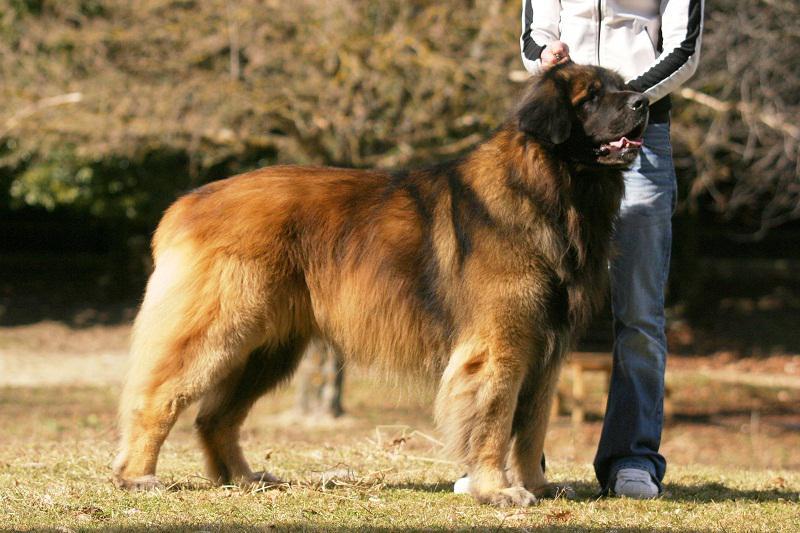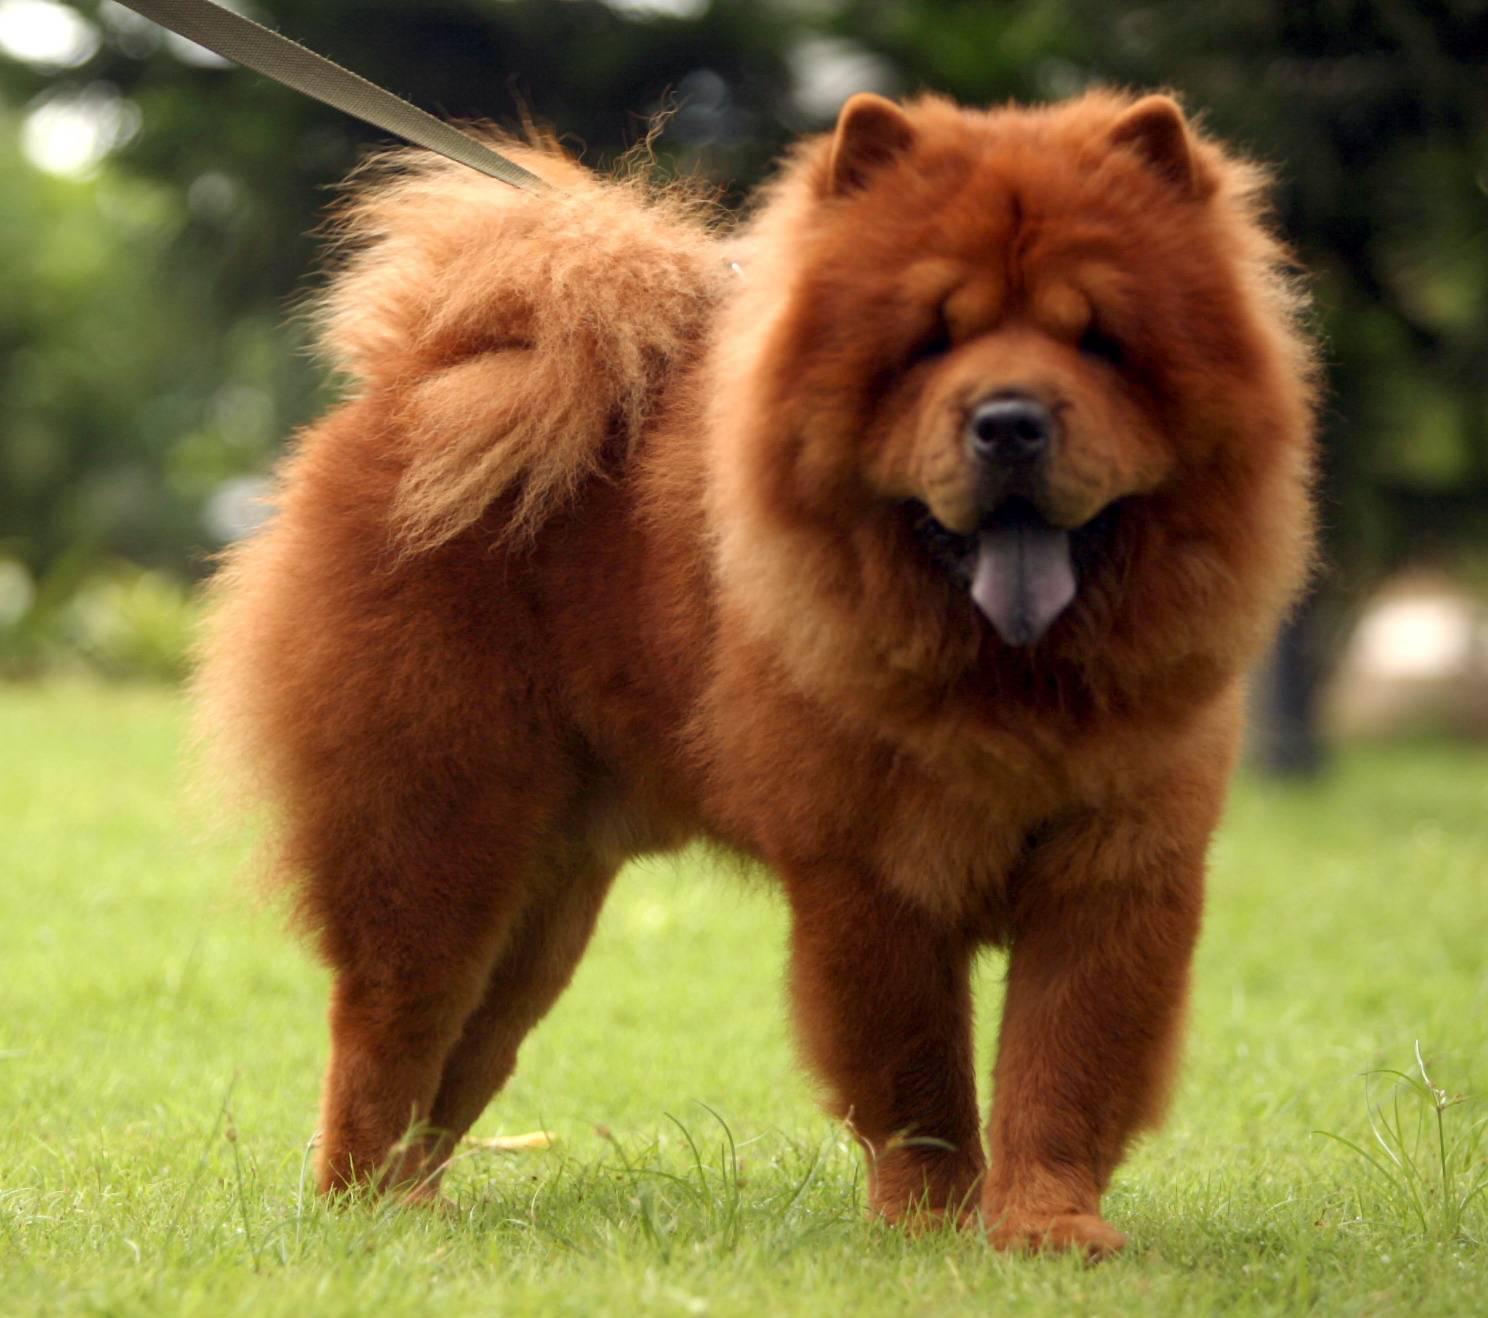The first image is the image on the left, the second image is the image on the right. Examine the images to the left and right. Is the description "There are three dogs" accurate? Answer yes or no. No. 